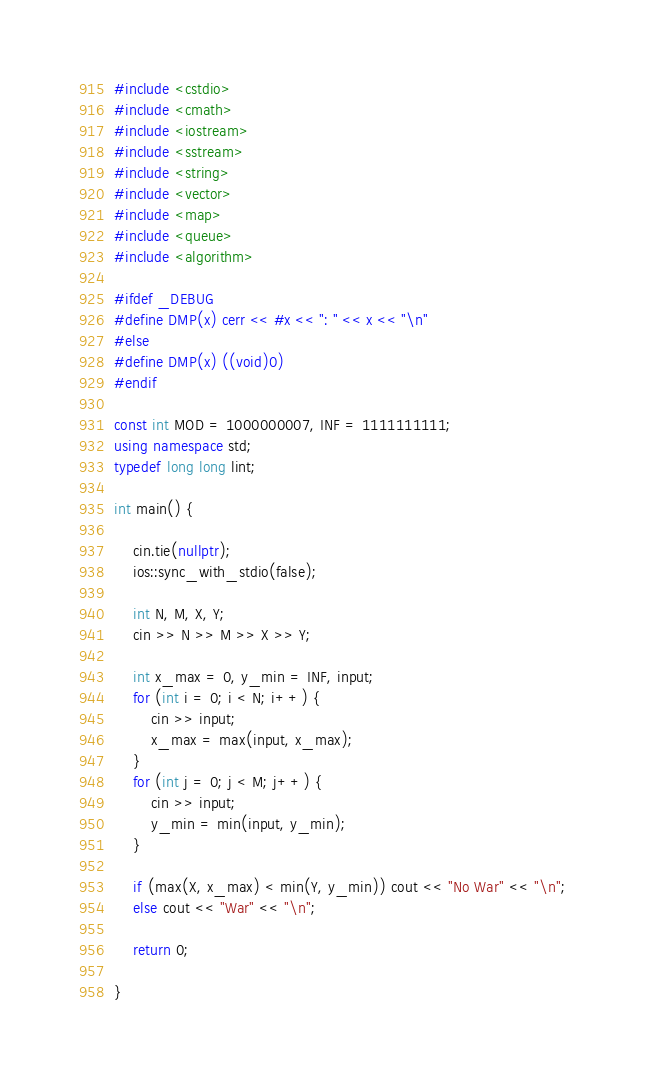<code> <loc_0><loc_0><loc_500><loc_500><_C++_>#include <cstdio>
#include <cmath>
#include <iostream>
#include <sstream>
#include <string>
#include <vector>
#include <map>
#include <queue>
#include <algorithm>

#ifdef _DEBUG
#define DMP(x) cerr << #x << ": " << x << "\n"
#else
#define DMP(x) ((void)0)
#endif

const int MOD = 1000000007, INF = 1111111111; 
using namespace std;
typedef long long lint;

int main() {

	cin.tie(nullptr);
	ios::sync_with_stdio(false);

	int N, M, X, Y;
	cin >> N >> M >> X >> Y;

	int x_max = 0, y_min = INF, input;
	for (int i = 0; i < N; i++) {
		cin >> input;
		x_max = max(input, x_max);
	}
	for (int j = 0; j < M; j++) {
		cin >> input;
		y_min = min(input, y_min);
	}

	if (max(X, x_max) < min(Y, y_min)) cout << "No War" << "\n";
	else cout << "War" << "\n";

	return 0;

}</code> 